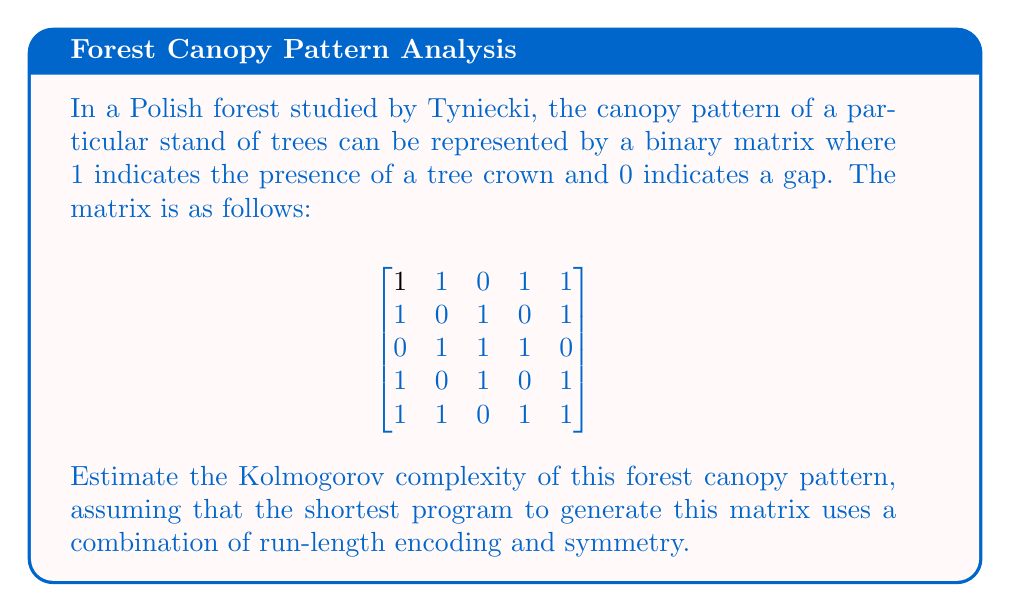What is the answer to this math problem? To estimate the Kolmogorov complexity, we need to find a concise way to describe the pattern:

1. First, observe that the matrix has rotational symmetry. We only need to describe the first three rows, as the last two are mirror images of the first two.

2. For the first three rows, we can use run-length encoding:
   Row 1: 2,1,2
   Row 2: 1,1,1,1,1
   Row 3: 1,3,1

3. We can represent this as: "2,1,2;1,1,1,1,1;1,3,1;mirror"

4. To encode this in binary:
   - We need 3 bits to represent each number (0-7 range)
   - We need 2 bits for each separator (;)
   - We need 6 bits for "mirror"

5. Calculation:
   (9 numbers × 3 bits) + (3 separators × 2 bits) + 6 bits = 39 bits

6. We also need a small program to interpret this encoding, which might add about 20-30 bits.

Therefore, an estimate of the Kolmogorov complexity is approximately 60-70 bits.
Answer: $\approx 65$ bits 